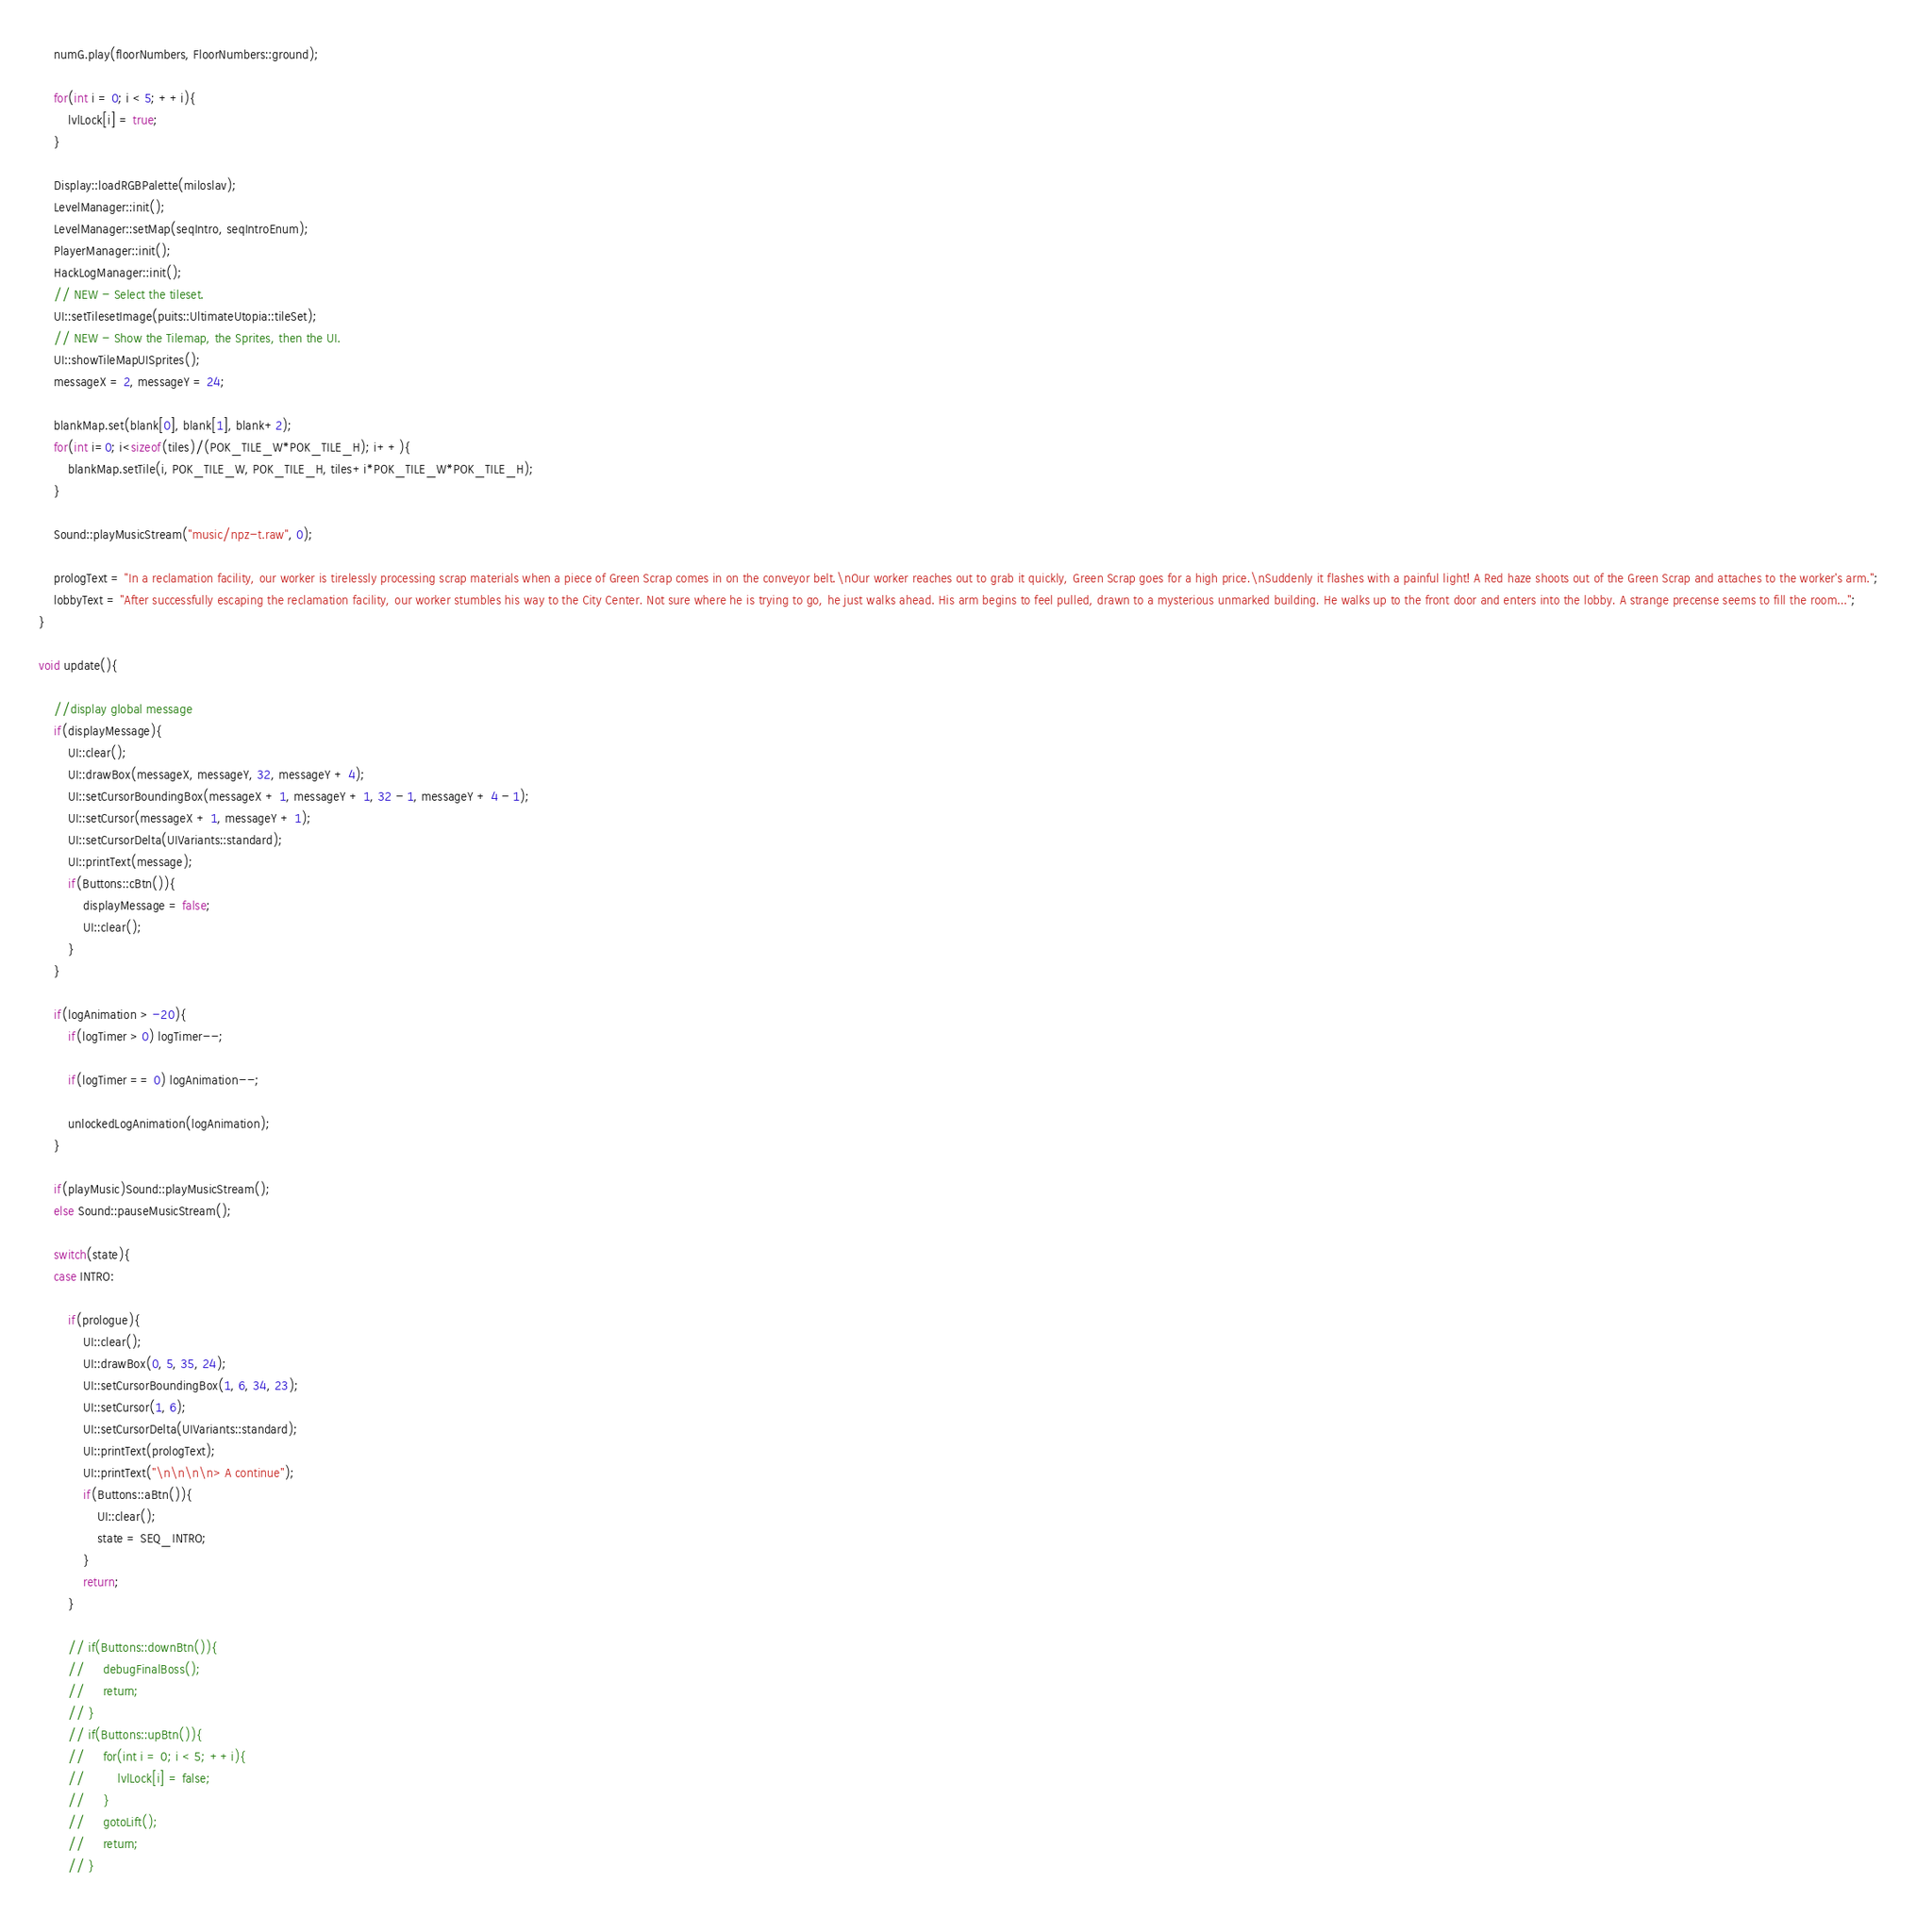Convert code to text. <code><loc_0><loc_0><loc_500><loc_500><_C++_>    numG.play(floorNumbers, FloorNumbers::ground);
    
    for(int i = 0; i < 5; ++i){
        lvlLock[i] = true;
    }
    
    Display::loadRGBPalette(miloslav);
    LevelManager::init();
    LevelManager::setMap(seqIntro, seqIntroEnum);
    PlayerManager::init();
    HackLogManager::init();
    // NEW - Select the tileset.
    UI::setTilesetImage(puits::UltimateUtopia::tileSet);
    // NEW - Show the Tilemap, the Sprites, then the UI.
    UI::showTileMapUISprites();
    messageX = 2, messageY = 24;
    
    blankMap.set(blank[0], blank[1], blank+2);
    for(int i=0; i<sizeof(tiles)/(POK_TILE_W*POK_TILE_H); i++){
        blankMap.setTile(i, POK_TILE_W, POK_TILE_H, tiles+i*POK_TILE_W*POK_TILE_H);
    }
    
    Sound::playMusicStream("music/npz-t.raw", 0);
    
    prologText = "In a reclamation facility, our worker is tirelessly processing scrap materials when a piece of Green Scrap comes in on the conveyor belt.\nOur worker reaches out to grab it quickly, Green Scrap goes for a high price.\nSuddenly it flashes with a painful light! A Red haze shoots out of the Green Scrap and attaches to the worker's arm.";
    lobbyText = "After successfully escaping the reclamation facility, our worker stumbles his way to the City Center. Not sure where he is trying to go, he just walks ahead. His arm begins to feel pulled, drawn to a mysterious unmarked building. He walks up to the front door and enters into the lobby. A strange precense seems to fill the room...";
}

void update(){
    
    //display global message
    if(displayMessage){
        UI::clear();
        UI::drawBox(messageX, messageY, 32, messageY + 4);
        UI::setCursorBoundingBox(messageX + 1, messageY + 1, 32 - 1, messageY + 4 - 1);
        UI::setCursor(messageX + 1, messageY + 1);
        UI::setCursorDelta(UIVariants::standard);
        UI::printText(message);
        if(Buttons::cBtn()){
            displayMessage = false;
            UI::clear();
        }
    }
    
    if(logAnimation > -20){
        if(logTimer > 0) logTimer--;
        
        if(logTimer == 0) logAnimation--;
        
        unlockedLogAnimation(logAnimation);
    }
    
    if(playMusic)Sound::playMusicStream();
    else Sound::pauseMusicStream();
    
    switch(state){
    case INTRO:
    
        if(prologue){
            UI::clear();
            UI::drawBox(0, 5, 35, 24);
            UI::setCursorBoundingBox(1, 6, 34, 23);
            UI::setCursor(1, 6);
            UI::setCursorDelta(UIVariants::standard);
            UI::printText(prologText);
            UI::printText("\n\n\n\n> A continue");
            if(Buttons::aBtn()){
                UI::clear();
                state = SEQ_INTRO;
            }
            return;
        }
    
        // if(Buttons::downBtn()){
        //     debugFinalBoss();
        //     return;
        // }
        // if(Buttons::upBtn()){
        //     for(int i = 0; i < 5; ++i){
        //         lvlLock[i] = false;
        //     }
        //     gotoLift();
        //     return;
        // }
        </code> 